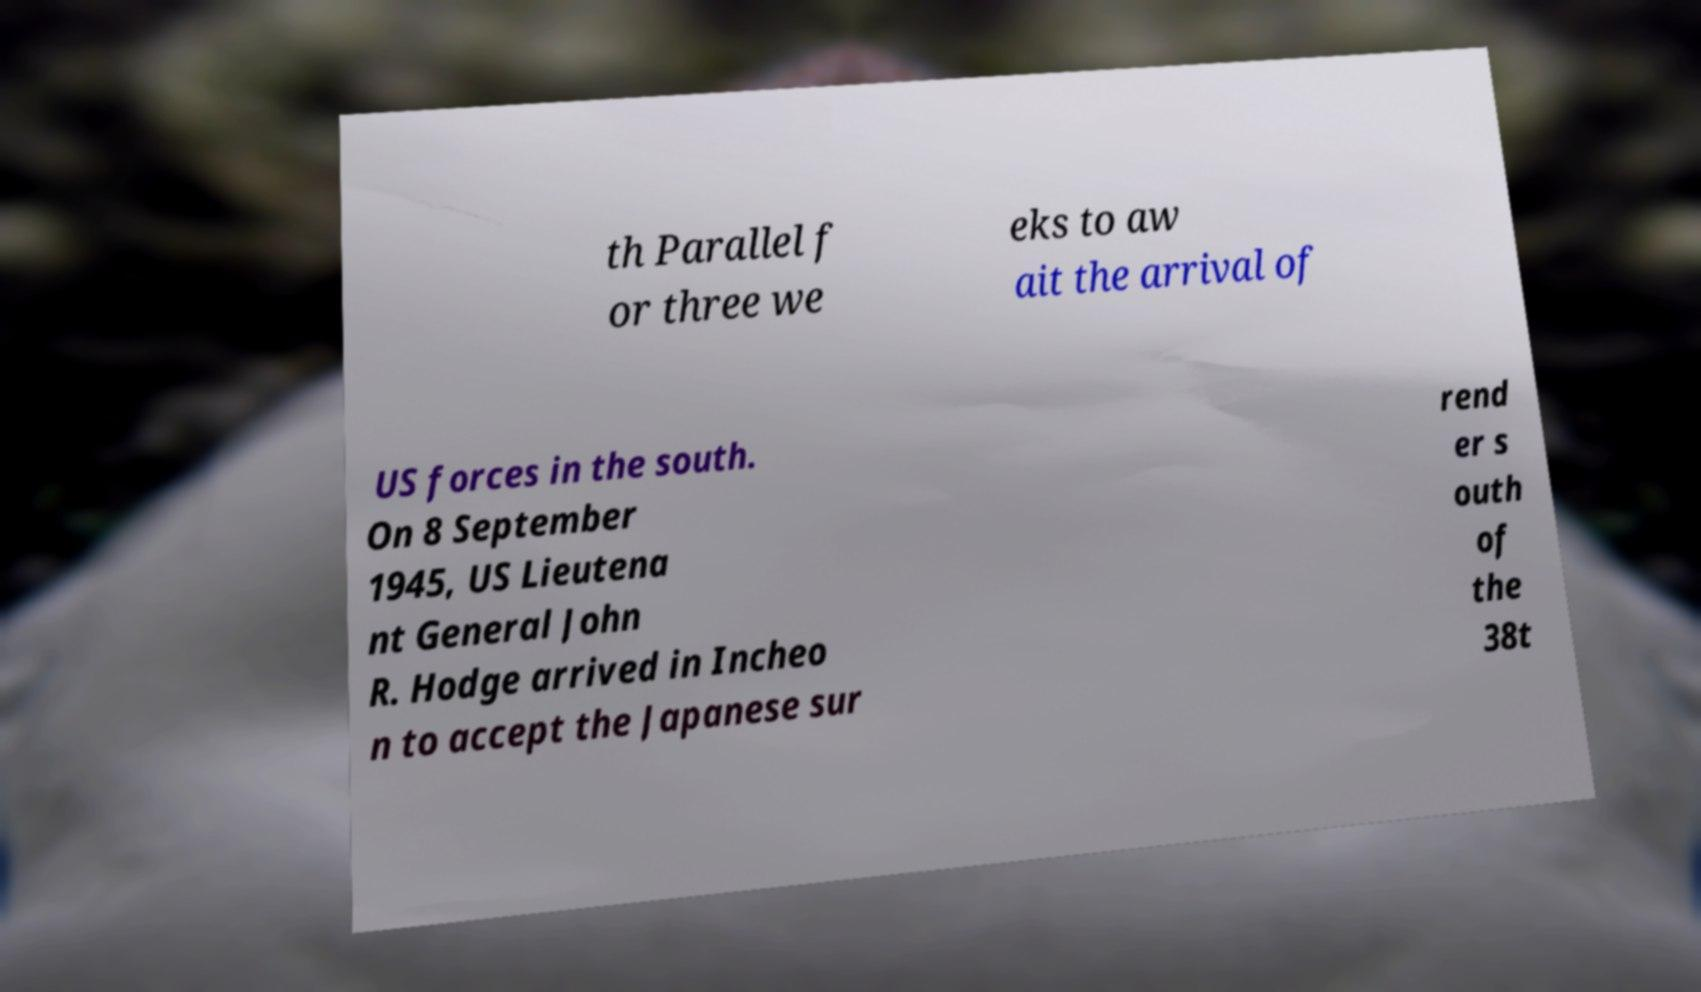There's text embedded in this image that I need extracted. Can you transcribe it verbatim? th Parallel f or three we eks to aw ait the arrival of US forces in the south. On 8 September 1945, US Lieutena nt General John R. Hodge arrived in Incheo n to accept the Japanese sur rend er s outh of the 38t 